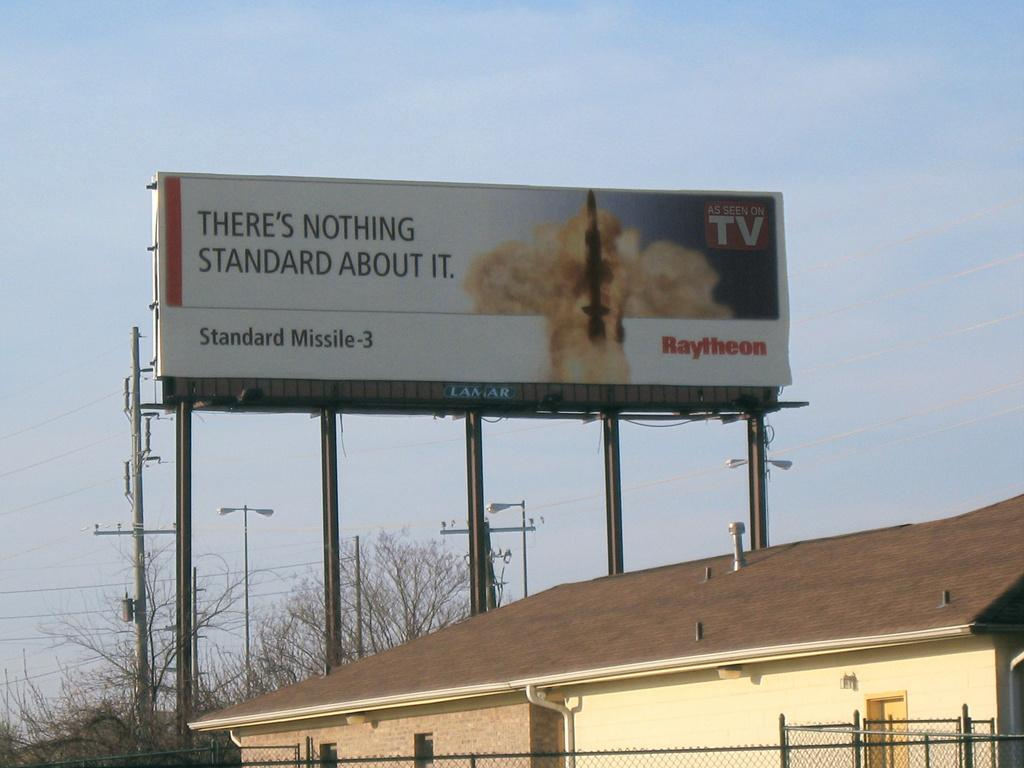<image>
Offer a succinct explanation of the picture presented. A large billboard above a brick house says As Seen On TV. 